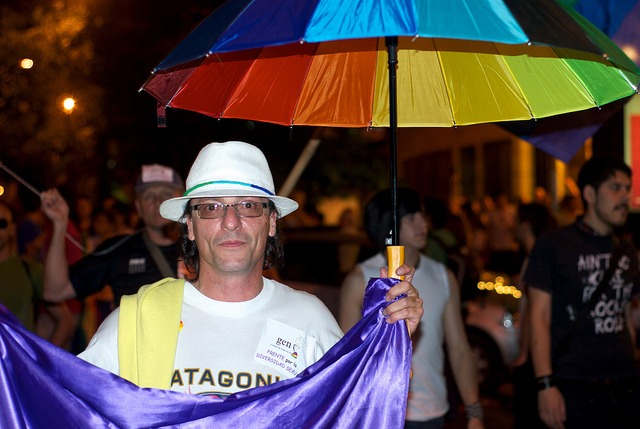What emotions does the person in the photo seem to be expressing? The person in the photo seems to be projecting a sense of pride and confidence, underscored by their direct gaze at the camera and the eclectic display of colorful accessories. The relaxed posture and slight smile convey a feeling of contentment and enjoyment typical of someone who is participating in a joyful and inclusive event. 